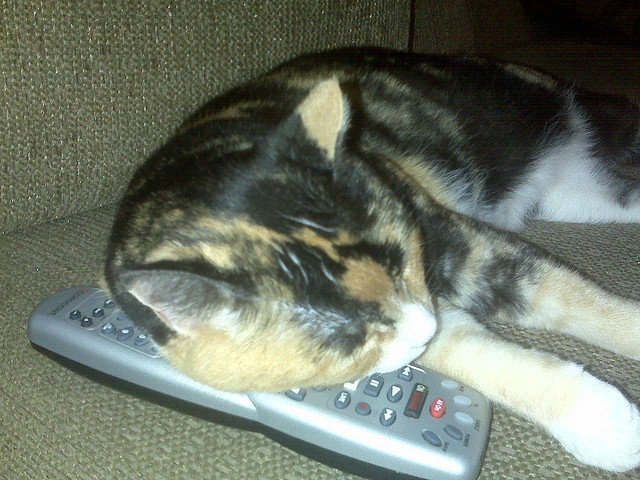Describe the objects in this image and their specific colors. I can see cat in darkgreen, black, gray, ivory, and darkgray tones, couch in darkgreen, gray, black, and darkgray tones, and remote in darkgreen, darkgray, gray, and white tones in this image. 